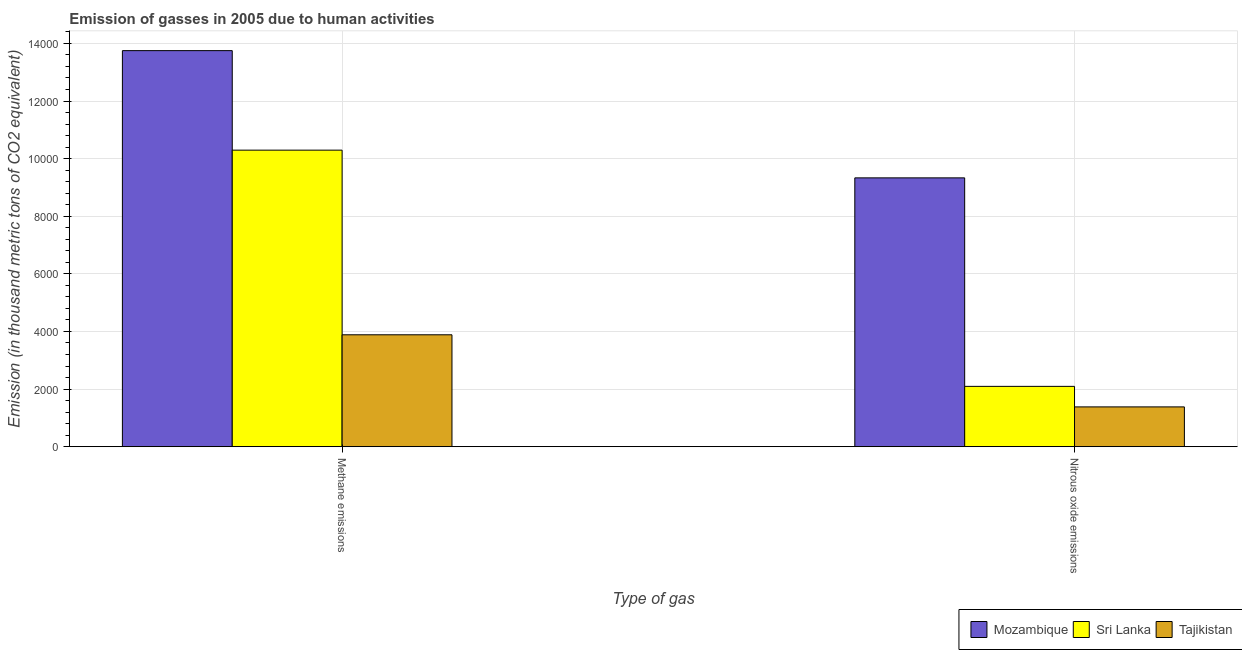How many different coloured bars are there?
Provide a short and direct response. 3. How many groups of bars are there?
Offer a terse response. 2. How many bars are there on the 2nd tick from the left?
Ensure brevity in your answer.  3. How many bars are there on the 2nd tick from the right?
Keep it short and to the point. 3. What is the label of the 2nd group of bars from the left?
Make the answer very short. Nitrous oxide emissions. What is the amount of nitrous oxide emissions in Mozambique?
Your response must be concise. 9332.5. Across all countries, what is the maximum amount of methane emissions?
Ensure brevity in your answer.  1.37e+04. Across all countries, what is the minimum amount of methane emissions?
Make the answer very short. 3884.9. In which country was the amount of methane emissions maximum?
Your answer should be very brief. Mozambique. In which country was the amount of methane emissions minimum?
Provide a succinct answer. Tajikistan. What is the total amount of methane emissions in the graph?
Your answer should be compact. 2.79e+04. What is the difference between the amount of methane emissions in Mozambique and that in Tajikistan?
Provide a succinct answer. 9864.6. What is the difference between the amount of nitrous oxide emissions in Tajikistan and the amount of methane emissions in Sri Lanka?
Offer a terse response. -8912.9. What is the average amount of methane emissions per country?
Your response must be concise. 9309.63. What is the difference between the amount of nitrous oxide emissions and amount of methane emissions in Tajikistan?
Ensure brevity in your answer.  -2503.3. What is the ratio of the amount of methane emissions in Sri Lanka to that in Mozambique?
Offer a very short reply. 0.75. Is the amount of nitrous oxide emissions in Sri Lanka less than that in Mozambique?
Your answer should be compact. Yes. What does the 3rd bar from the left in Methane emissions represents?
Offer a very short reply. Tajikistan. What does the 1st bar from the right in Nitrous oxide emissions represents?
Your answer should be compact. Tajikistan. How many bars are there?
Give a very brief answer. 6. How many countries are there in the graph?
Keep it short and to the point. 3. Are the values on the major ticks of Y-axis written in scientific E-notation?
Give a very brief answer. No. Where does the legend appear in the graph?
Provide a short and direct response. Bottom right. How many legend labels are there?
Your response must be concise. 3. How are the legend labels stacked?
Offer a very short reply. Horizontal. What is the title of the graph?
Make the answer very short. Emission of gasses in 2005 due to human activities. Does "Kuwait" appear as one of the legend labels in the graph?
Your answer should be very brief. No. What is the label or title of the X-axis?
Offer a terse response. Type of gas. What is the label or title of the Y-axis?
Make the answer very short. Emission (in thousand metric tons of CO2 equivalent). What is the Emission (in thousand metric tons of CO2 equivalent) of Mozambique in Methane emissions?
Offer a terse response. 1.37e+04. What is the Emission (in thousand metric tons of CO2 equivalent) in Sri Lanka in Methane emissions?
Your answer should be very brief. 1.03e+04. What is the Emission (in thousand metric tons of CO2 equivalent) of Tajikistan in Methane emissions?
Keep it short and to the point. 3884.9. What is the Emission (in thousand metric tons of CO2 equivalent) of Mozambique in Nitrous oxide emissions?
Your answer should be very brief. 9332.5. What is the Emission (in thousand metric tons of CO2 equivalent) in Sri Lanka in Nitrous oxide emissions?
Your answer should be very brief. 2094.1. What is the Emission (in thousand metric tons of CO2 equivalent) in Tajikistan in Nitrous oxide emissions?
Make the answer very short. 1381.6. Across all Type of gas, what is the maximum Emission (in thousand metric tons of CO2 equivalent) in Mozambique?
Keep it short and to the point. 1.37e+04. Across all Type of gas, what is the maximum Emission (in thousand metric tons of CO2 equivalent) in Sri Lanka?
Ensure brevity in your answer.  1.03e+04. Across all Type of gas, what is the maximum Emission (in thousand metric tons of CO2 equivalent) of Tajikistan?
Provide a short and direct response. 3884.9. Across all Type of gas, what is the minimum Emission (in thousand metric tons of CO2 equivalent) of Mozambique?
Provide a short and direct response. 9332.5. Across all Type of gas, what is the minimum Emission (in thousand metric tons of CO2 equivalent) of Sri Lanka?
Provide a short and direct response. 2094.1. Across all Type of gas, what is the minimum Emission (in thousand metric tons of CO2 equivalent) of Tajikistan?
Your answer should be compact. 1381.6. What is the total Emission (in thousand metric tons of CO2 equivalent) of Mozambique in the graph?
Give a very brief answer. 2.31e+04. What is the total Emission (in thousand metric tons of CO2 equivalent) of Sri Lanka in the graph?
Offer a terse response. 1.24e+04. What is the total Emission (in thousand metric tons of CO2 equivalent) of Tajikistan in the graph?
Your answer should be compact. 5266.5. What is the difference between the Emission (in thousand metric tons of CO2 equivalent) of Mozambique in Methane emissions and that in Nitrous oxide emissions?
Give a very brief answer. 4417. What is the difference between the Emission (in thousand metric tons of CO2 equivalent) in Sri Lanka in Methane emissions and that in Nitrous oxide emissions?
Give a very brief answer. 8200.4. What is the difference between the Emission (in thousand metric tons of CO2 equivalent) in Tajikistan in Methane emissions and that in Nitrous oxide emissions?
Your response must be concise. 2503.3. What is the difference between the Emission (in thousand metric tons of CO2 equivalent) of Mozambique in Methane emissions and the Emission (in thousand metric tons of CO2 equivalent) of Sri Lanka in Nitrous oxide emissions?
Offer a terse response. 1.17e+04. What is the difference between the Emission (in thousand metric tons of CO2 equivalent) of Mozambique in Methane emissions and the Emission (in thousand metric tons of CO2 equivalent) of Tajikistan in Nitrous oxide emissions?
Your answer should be very brief. 1.24e+04. What is the difference between the Emission (in thousand metric tons of CO2 equivalent) of Sri Lanka in Methane emissions and the Emission (in thousand metric tons of CO2 equivalent) of Tajikistan in Nitrous oxide emissions?
Give a very brief answer. 8912.9. What is the average Emission (in thousand metric tons of CO2 equivalent) in Mozambique per Type of gas?
Ensure brevity in your answer.  1.15e+04. What is the average Emission (in thousand metric tons of CO2 equivalent) of Sri Lanka per Type of gas?
Your answer should be compact. 6194.3. What is the average Emission (in thousand metric tons of CO2 equivalent) in Tajikistan per Type of gas?
Give a very brief answer. 2633.25. What is the difference between the Emission (in thousand metric tons of CO2 equivalent) of Mozambique and Emission (in thousand metric tons of CO2 equivalent) of Sri Lanka in Methane emissions?
Your response must be concise. 3455. What is the difference between the Emission (in thousand metric tons of CO2 equivalent) in Mozambique and Emission (in thousand metric tons of CO2 equivalent) in Tajikistan in Methane emissions?
Offer a terse response. 9864.6. What is the difference between the Emission (in thousand metric tons of CO2 equivalent) in Sri Lanka and Emission (in thousand metric tons of CO2 equivalent) in Tajikistan in Methane emissions?
Your answer should be very brief. 6409.6. What is the difference between the Emission (in thousand metric tons of CO2 equivalent) in Mozambique and Emission (in thousand metric tons of CO2 equivalent) in Sri Lanka in Nitrous oxide emissions?
Your answer should be very brief. 7238.4. What is the difference between the Emission (in thousand metric tons of CO2 equivalent) in Mozambique and Emission (in thousand metric tons of CO2 equivalent) in Tajikistan in Nitrous oxide emissions?
Your answer should be very brief. 7950.9. What is the difference between the Emission (in thousand metric tons of CO2 equivalent) of Sri Lanka and Emission (in thousand metric tons of CO2 equivalent) of Tajikistan in Nitrous oxide emissions?
Your answer should be very brief. 712.5. What is the ratio of the Emission (in thousand metric tons of CO2 equivalent) of Mozambique in Methane emissions to that in Nitrous oxide emissions?
Keep it short and to the point. 1.47. What is the ratio of the Emission (in thousand metric tons of CO2 equivalent) of Sri Lanka in Methane emissions to that in Nitrous oxide emissions?
Ensure brevity in your answer.  4.92. What is the ratio of the Emission (in thousand metric tons of CO2 equivalent) of Tajikistan in Methane emissions to that in Nitrous oxide emissions?
Ensure brevity in your answer.  2.81. What is the difference between the highest and the second highest Emission (in thousand metric tons of CO2 equivalent) in Mozambique?
Give a very brief answer. 4417. What is the difference between the highest and the second highest Emission (in thousand metric tons of CO2 equivalent) in Sri Lanka?
Your answer should be very brief. 8200.4. What is the difference between the highest and the second highest Emission (in thousand metric tons of CO2 equivalent) of Tajikistan?
Provide a short and direct response. 2503.3. What is the difference between the highest and the lowest Emission (in thousand metric tons of CO2 equivalent) of Mozambique?
Offer a very short reply. 4417. What is the difference between the highest and the lowest Emission (in thousand metric tons of CO2 equivalent) in Sri Lanka?
Give a very brief answer. 8200.4. What is the difference between the highest and the lowest Emission (in thousand metric tons of CO2 equivalent) in Tajikistan?
Ensure brevity in your answer.  2503.3. 